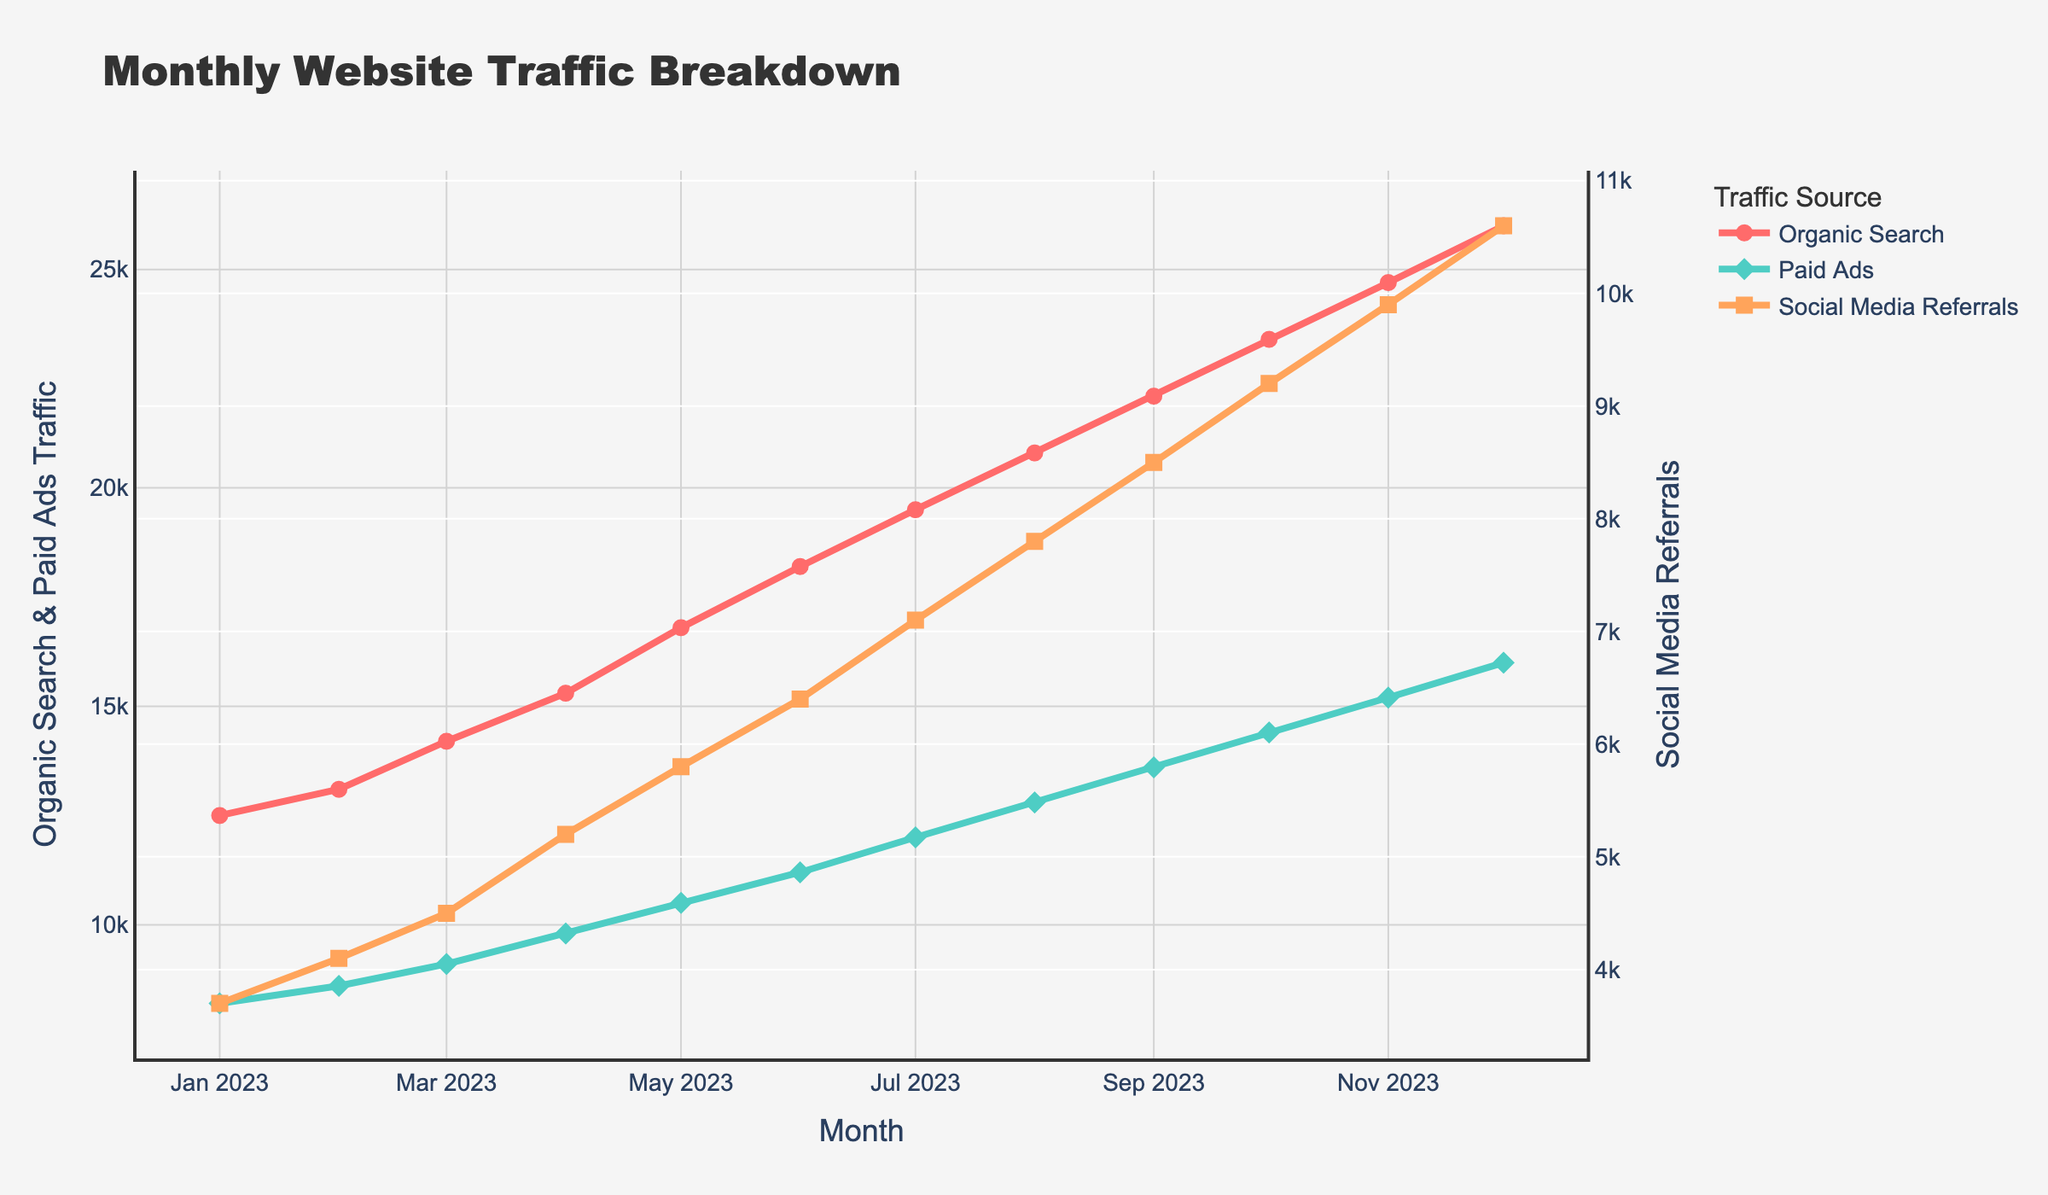Which month saw the highest website traffic from Organic Search? The highest point on the red line that represents Organic Search is in December 2023 at 26,000 visitors.
Answer: December 2023 How much did the traffic from Paid Ads increase from January 2023 to December 2023? In January 2023, the traffic from Paid Ads was 8,200. In December 2023, it was 16,000. The increase is 16,000 - 8,200 = 7,800.
Answer: 7,800 Compare the trends of Social Media Referrals and Organic Search. Are they both increasing, decreasing, or showing different trends? The orange line representing Social Media Referrals consistently rises from January to December, as does the red line representing Organic Search, indicating both trends are increasing.
Answer: Both increasing What is the average traffic from Social Media Referrals over the year 2023? The sum of Social Media Referrals traffic values is 3700 + 4100 + 4500 + 5200 + 5800 + 6400 + 7100 + 7800 + 8500 + 9200 + 9900 + 10600 = 90,500. There are 12 months, so the average is 90,500 / 12 = 7,542.
Answer: 7,542 Which traffic source showed the most significant growth between two consecutive months, and in which months did it happen? The blue line for Paid Ads shows the highest single month growth between November 2023 (15,200) and December 2023 (16,000), which is 16,000 - 15,200 = 800.
Answer: Paid Ads, between November and December 2023 By how much did the traffic from Social Media Referrals grow between January 2023 and December 2023? In January 2023, the traffic from Social Media Referrals was 3,700. In December 2023, it was 10,600. The growth is 10,600 - 3,700 = 6,900.
Answer: 6,900 What is the combined website traffic from all sources in June 2023? Adding traffic from all categories in June 2023: Organic Search (18,200) + Paid Ads (11,200) + Social Media Referrals (6,400) = 35,800.
Answer: 35,800 